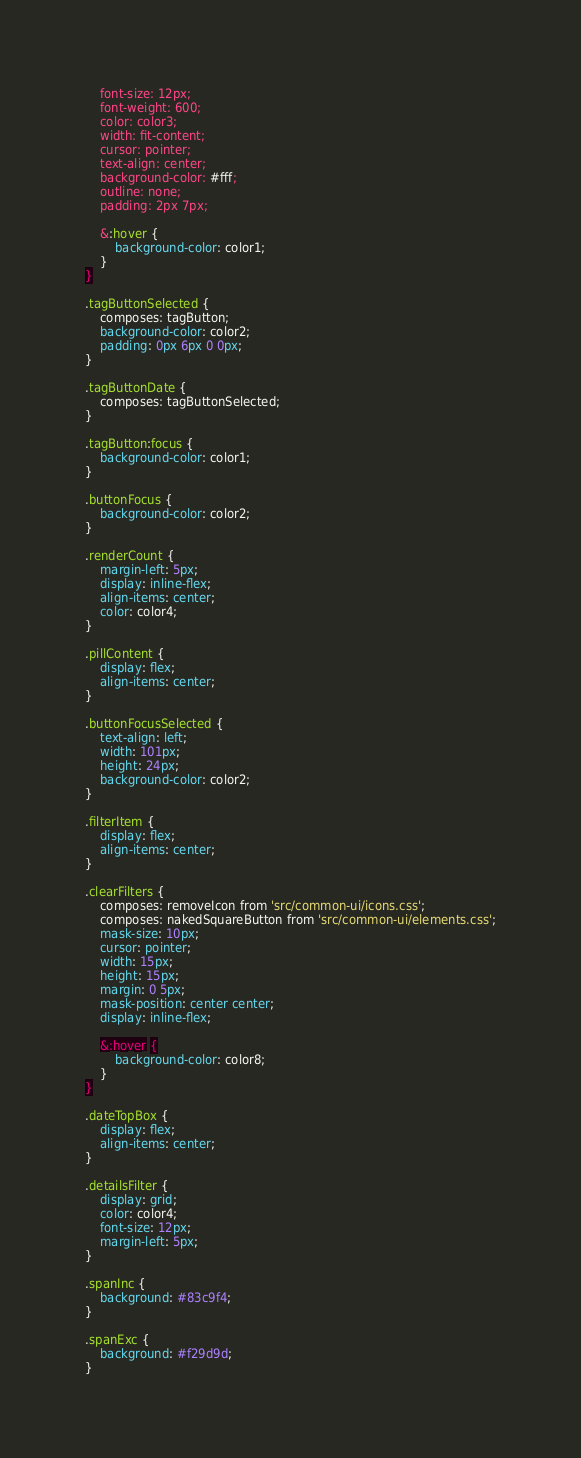Convert code to text. <code><loc_0><loc_0><loc_500><loc_500><_CSS_>    font-size: 12px;
    font-weight: 600;
    color: color3;
    width: fit-content;
    cursor: pointer;
    text-align: center;
    background-color: #fff;
    outline: none;
    padding: 2px 7px;

    &:hover {
        background-color: color1;
    }
}

.tagButtonSelected {
    composes: tagButton;
    background-color: color2;
    padding: 0px 6px 0 0px;
}

.tagButtonDate {
    composes: tagButtonSelected;
}

.tagButton:focus {
    background-color: color1;
}

.buttonFocus {
    background-color: color2;
}

.renderCount {
    margin-left: 5px;
    display: inline-flex;
    align-items: center;
    color: color4;
}

.pillContent {
    display: flex;
    align-items: center;
}

.buttonFocusSelected {
    text-align: left;
    width: 101px;
    height: 24px;
    background-color: color2;
}

.filterItem {
    display: flex;
    align-items: center;
}

.clearFilters {
    composes: removeIcon from 'src/common-ui/icons.css';
    composes: nakedSquareButton from 'src/common-ui/elements.css';
    mask-size: 10px;
    cursor: pointer;
    width: 15px;
    height: 15px;
    margin: 0 5px;
    mask-position: center center;
    display: inline-flex;

    &:hover {
        background-color: color8;
    }
}

.dateTopBox {
    display: flex;
    align-items: center;
}

.detailsFilter {
    display: grid;
    color: color4;
    font-size: 12px;
    margin-left: 5px;
}

.spanInc {
    background: #83c9f4;
}

.spanExc {
    background: #f29d9d;
}
</code> 